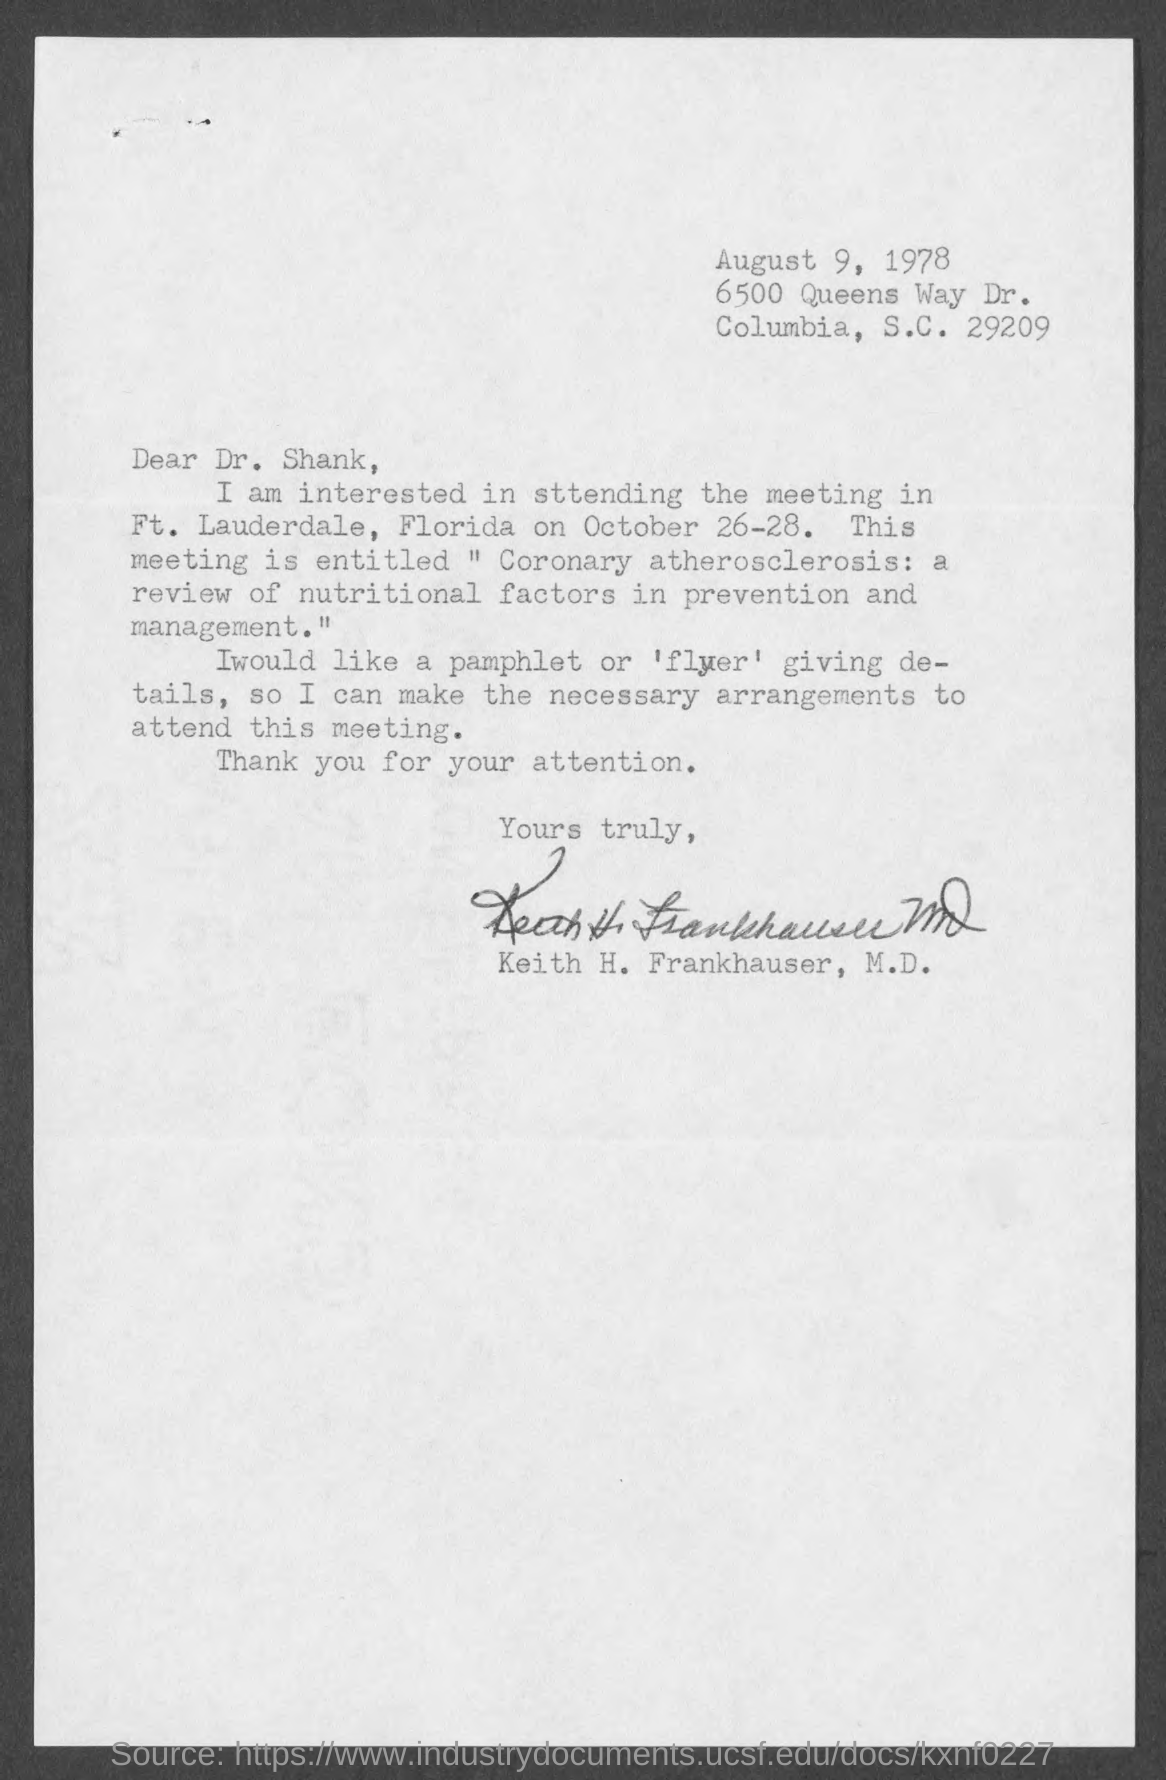What is the Date mentioned in the top of the document ?
Keep it short and to the point. August 9, 1978. Who is the Memorandum Addressed to ?
Provide a short and direct response. Dr. Shank,. 